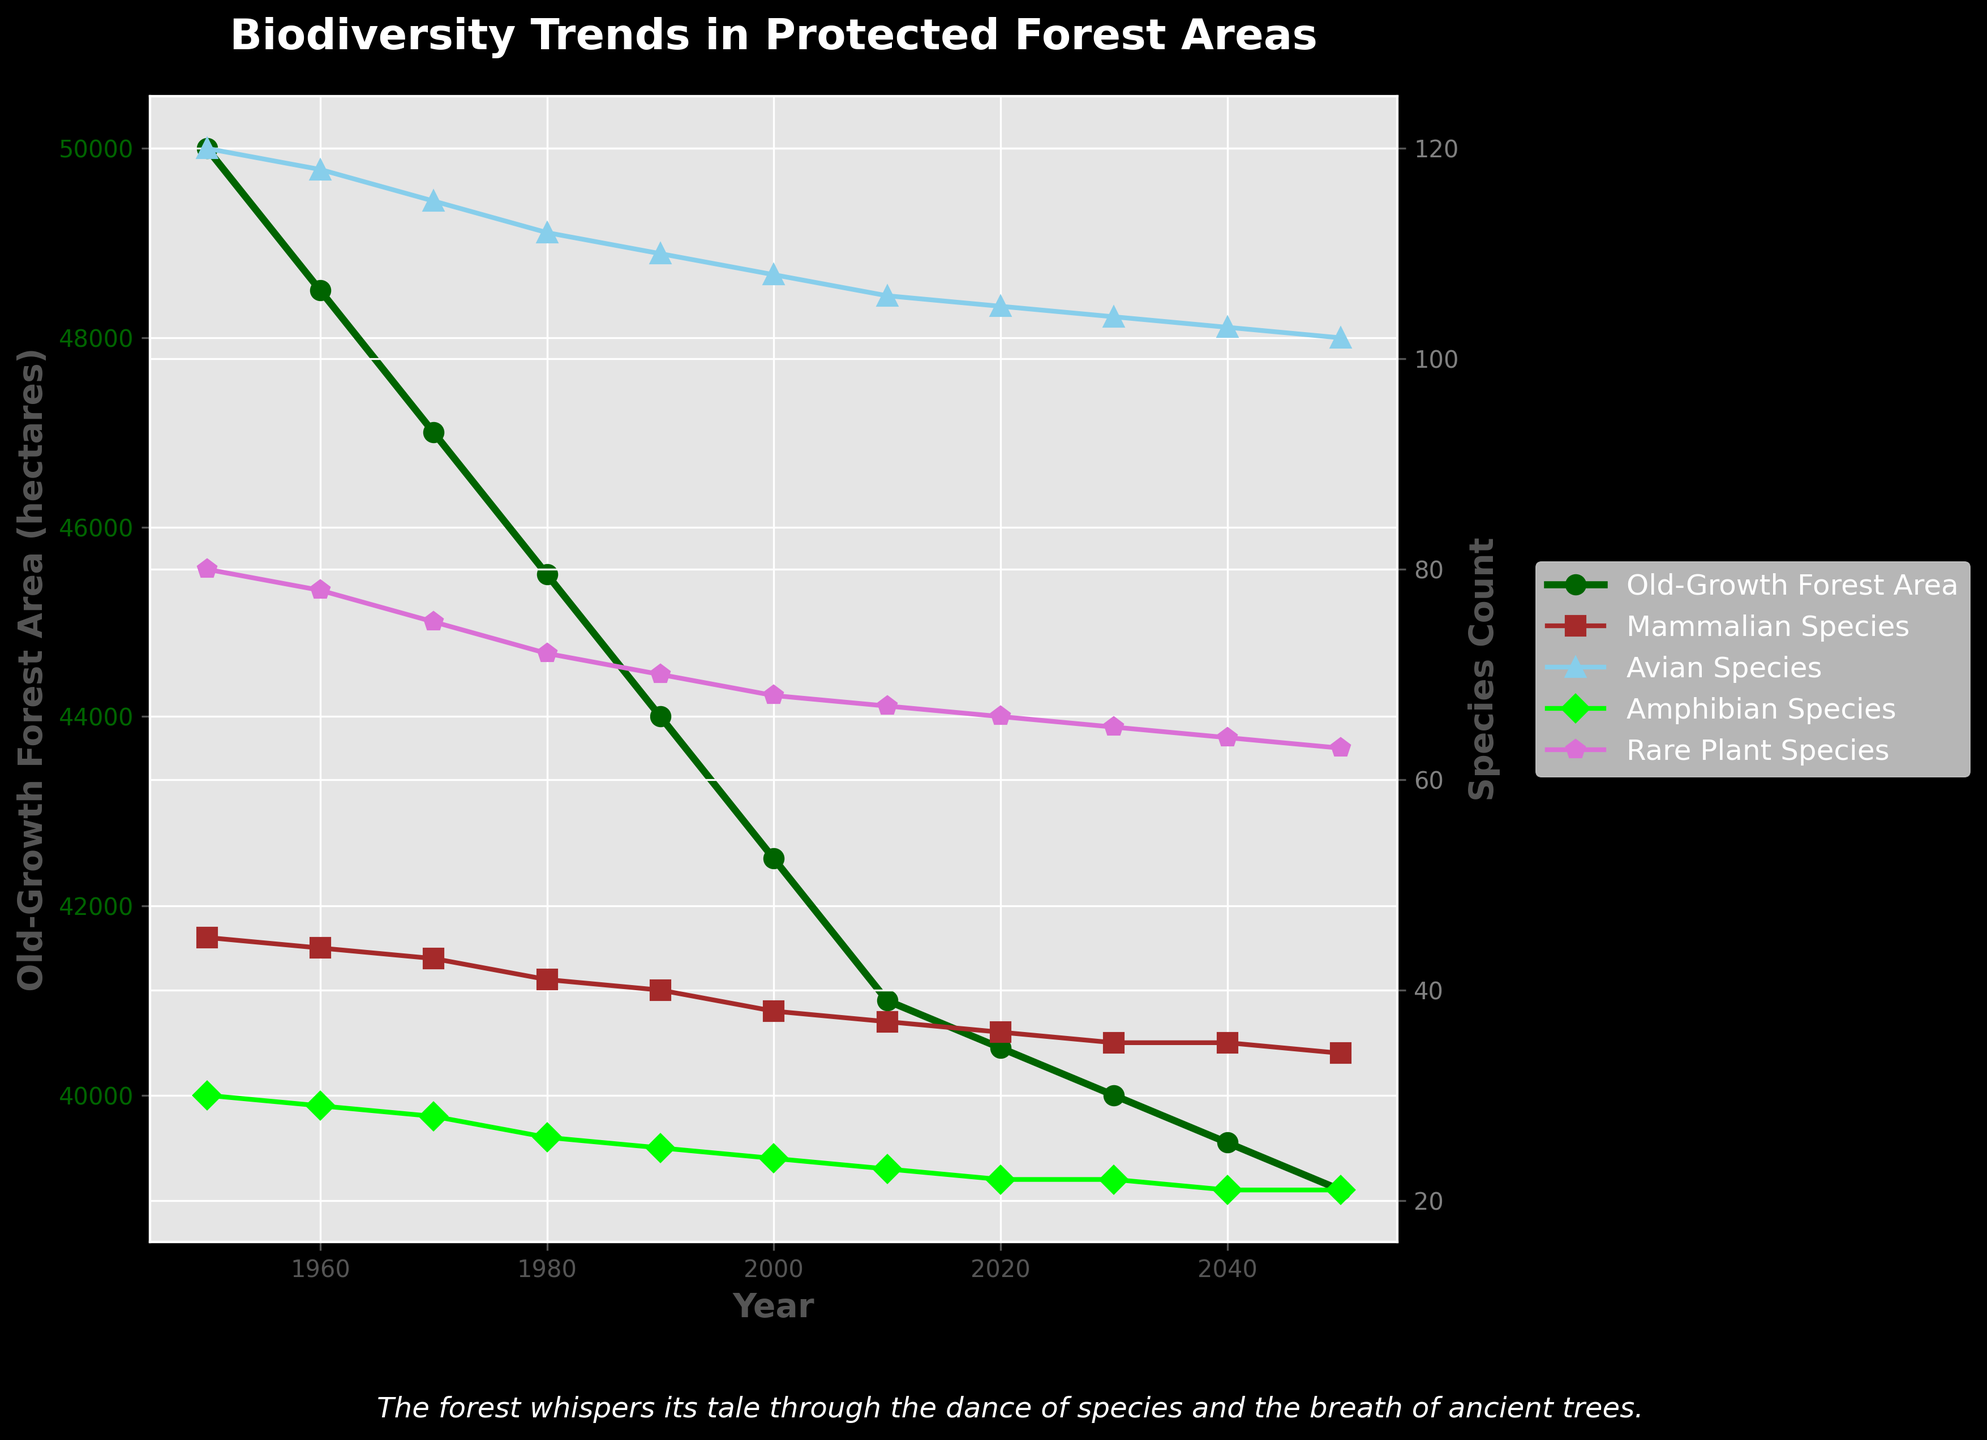what is the overall trend in Old-Growth Forest Area from 1950 to 2050? The Old-Growth Forest Area shows a decreasing trend over the years, decreasing from 50,000 hectares in 1950 to 39,000 hectares in 2050.
Answer: Decreasing How has the count of Rare Plant Species changed from 1950 to 2050? The count of Rare Plant Species has gradually declined from 80 species in 1950 to 63 species in 2050.
Answer: Declined Between which two decades did the Amphibian Species Count drop the most significantly? By comparing the changes in Amphibian Species Count between consecutive decades, the most significant drop occurred between 1980 (26 species) and 1990 (25 species), which is a drop of 2 species.
Answer: 1980 and 1990 Which species count is the highest in 2050, and what is its value? According to the plotted species counts for 2050, the Avian Species Count is the highest, with a count of 102 species.
Answer: Avian Species, 102 What is the total number of Mammalian and Amphibian Species in 2000? To find the total number, add the Mammalian Species Count (38) and the Amphibian Species Count (24) for the year 2000: 38 + 24 = 62.
Answer: 62 How does the species diversity change over time in terms of visual representation? All species counts (Mammalian, Avian, Amphibian, and Rare Plant) show a downward trend, each depicted by lines of different colors declining over time.
Answer: Decreased across all species In what year did the Old-Growth Forest Area fall below 45,000 hectares for the first time? Form the graph, the Old-Growth Forest Area first falls below 45,000 hectares in 1980 with a value of 45,500 hectares.
Answer: 1980 Compare the change in Avian Species Count between 1950 and 2050. What is the difference? The Avian Species Count decreased from 120 species in 1950 to 102 species in 2050. The difference is 120 - 102 = 18 species.
Answer: 18 Which species has the least change in its count from 1950 to 2050? By examining the plotted lines, Mammalian Species have a decrease from 45 to 34. But Amphibian Species change from 30 to 21, which is a difference of 9, the least change among all species.
Answer: Mammalian 